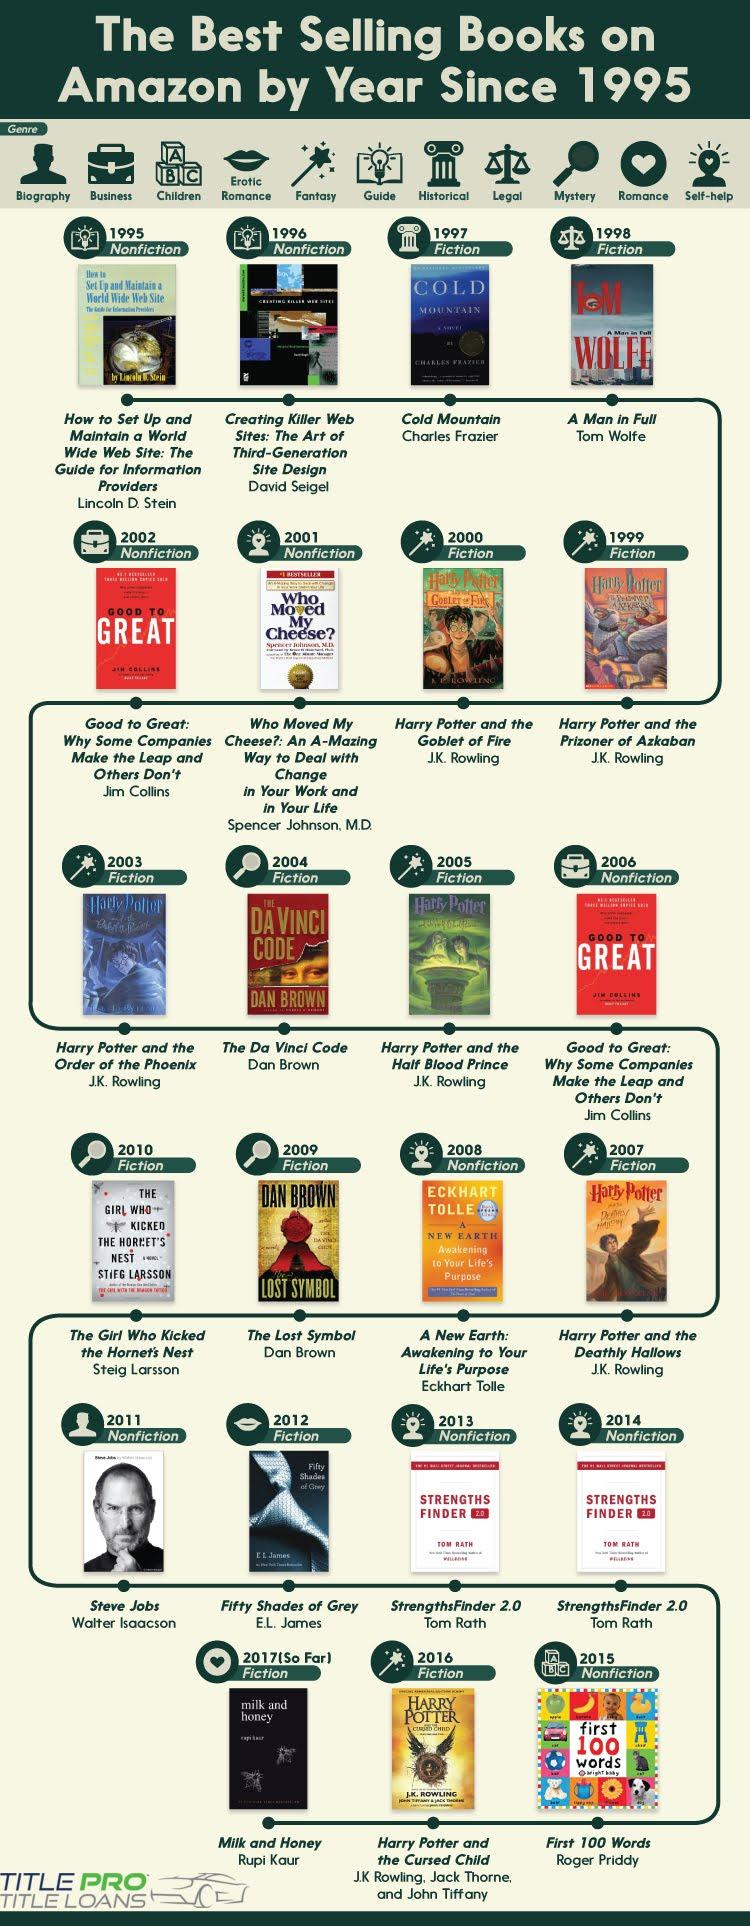Mention a couple of crucial points in this snapshot. Cold Mountain was the best-selling book in the year 1997. The genre of the book "A Man in Full" is fiction. It is reported that Dan Brown has authored two best-selling books. The infographic contains 13 fiction books. Tom Rath has written two best-selling books. 